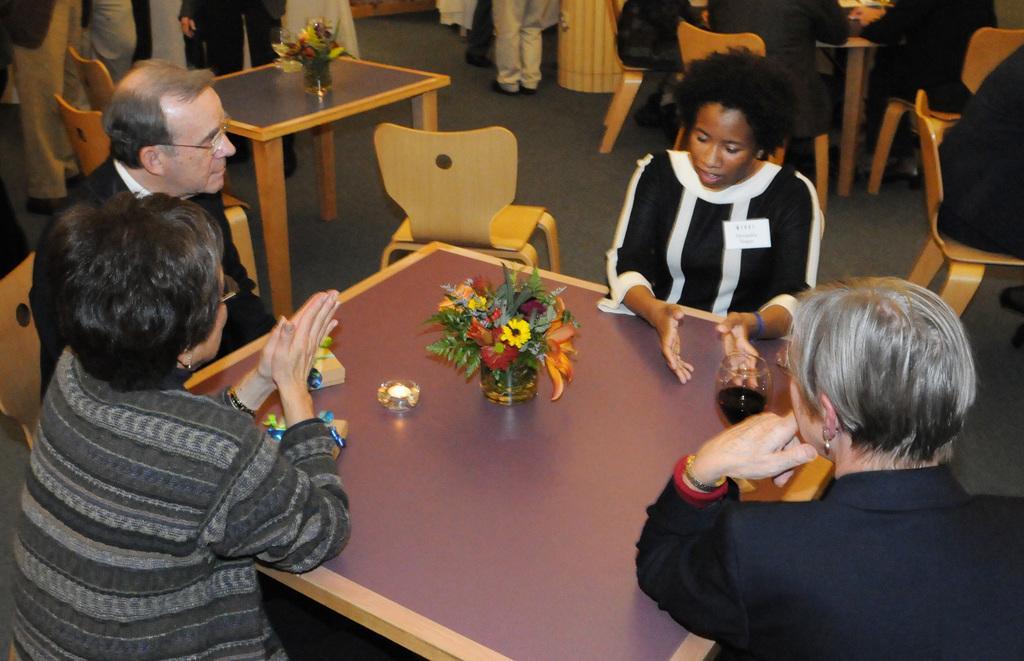How would you summarize this image in a sentence or two? In this image i can see 3 women and a man sitting around a table. On the table i can see a flower vase. In the background i can see few people standing and few people sitting. 